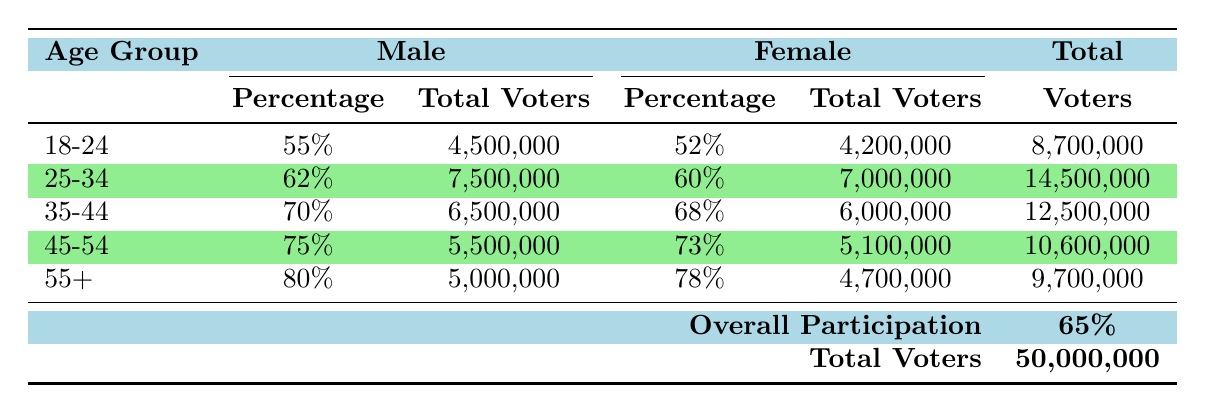What is the overall electoral participation rate in Karnataka for the 2024 elections? The table states that the overall participation rate is listed directly under "Overall Participation," which is 65%.
Answer: 65% Which age group has the highest electoral participation rate among males? The highest participation rate among males can be found by comparing the percentages in the Male column across all age groups. The 55+ age group has the highest rate at 80%.
Answer: 80% How many total voters participated in the 25-34 age group? To find the total voters in the 25-34 age group, we can add the total voters for males and females in that age group: 7,500,000 (male) + 7,000,000 (female) = 14,500,000.
Answer: 14,500,000 Which gender has a higher participation rate in the 35-44 age group? By looking at the Percentages in the 35-44 age group for both genders, we see that 70% for males is higher than 68% for females.
Answer: Male What is the average participation rate for females across all age groups? To calculate the average, sum the participation rates for females: (52 + 60 + 68 + 73 + 78) = 331. Then divide by the number of age groups (5): 331/5 = 66.2%.
Answer: 66.2% Is it true that the total number of voters in the 45-54 age group is greater than in the 18-24 age group? The total voters for the 45-54 age group is 5,500,000 (male) + 5,100,000 (female) = 10,600,000 and for the 18-24 age group it is 4,500,000 (male) + 4,200,000 (female) = 8,700,000. Since 10,600,000 is greater than 8,700,000, the statement is true.
Answer: True What is the difference in the total number of voters between the 55+ age group and the 25-34 age group? First, calculate the total for each age group: 55+ has 5,000,000 (male) + 4,700,000 (female) = 9,700,000. For 25-34: 7,500,000 (male) + 7,000,000 (female) = 14,500,000. The difference is 14,500,000 - 9,700,000 = 4,800,000.
Answer: 4,800,000 Which age group has the lowest participation rate among females? By checking the Female percentages in all age groups, we see that the 18-24 age group has the lowest rate at 52%.
Answer: 52% 